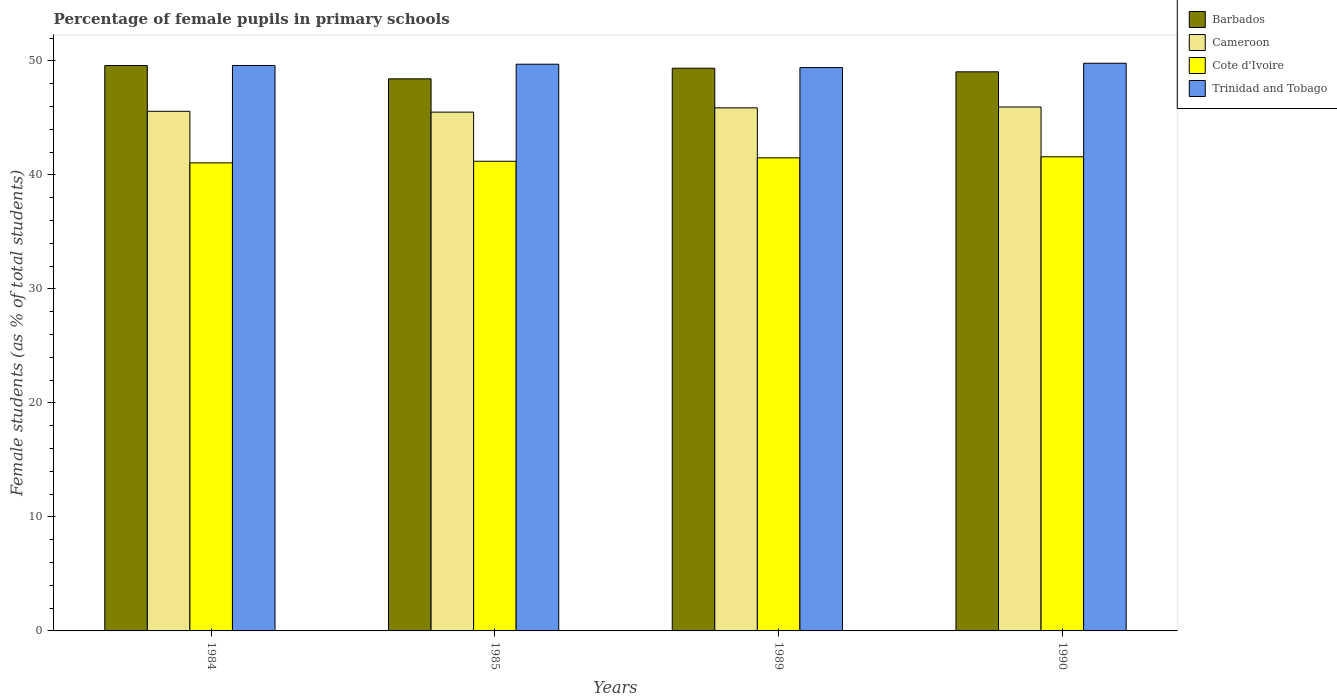How many groups of bars are there?
Your answer should be very brief. 4. Are the number of bars per tick equal to the number of legend labels?
Make the answer very short. Yes. Are the number of bars on each tick of the X-axis equal?
Make the answer very short. Yes. How many bars are there on the 2nd tick from the left?
Your answer should be very brief. 4. What is the label of the 1st group of bars from the left?
Your answer should be very brief. 1984. In how many cases, is the number of bars for a given year not equal to the number of legend labels?
Offer a terse response. 0. What is the percentage of female pupils in primary schools in Cameroon in 1985?
Your answer should be compact. 45.51. Across all years, what is the maximum percentage of female pupils in primary schools in Cote d'Ivoire?
Your answer should be compact. 41.59. Across all years, what is the minimum percentage of female pupils in primary schools in Barbados?
Your answer should be compact. 48.42. In which year was the percentage of female pupils in primary schools in Cameroon minimum?
Provide a short and direct response. 1985. What is the total percentage of female pupils in primary schools in Barbados in the graph?
Your answer should be very brief. 196.41. What is the difference between the percentage of female pupils in primary schools in Cameroon in 1989 and that in 1990?
Offer a terse response. -0.08. What is the difference between the percentage of female pupils in primary schools in Barbados in 1985 and the percentage of female pupils in primary schools in Cameroon in 1990?
Your answer should be compact. 2.47. What is the average percentage of female pupils in primary schools in Cote d'Ivoire per year?
Offer a very short reply. 41.33. In the year 1990, what is the difference between the percentage of female pupils in primary schools in Trinidad and Tobago and percentage of female pupils in primary schools in Cote d'Ivoire?
Your response must be concise. 8.2. What is the ratio of the percentage of female pupils in primary schools in Barbados in 1985 to that in 1990?
Make the answer very short. 0.99. Is the difference between the percentage of female pupils in primary schools in Trinidad and Tobago in 1984 and 1989 greater than the difference between the percentage of female pupils in primary schools in Cote d'Ivoire in 1984 and 1989?
Your response must be concise. Yes. What is the difference between the highest and the second highest percentage of female pupils in primary schools in Cote d'Ivoire?
Provide a succinct answer. 0.09. What is the difference between the highest and the lowest percentage of female pupils in primary schools in Barbados?
Provide a succinct answer. 1.17. What does the 3rd bar from the left in 1990 represents?
Give a very brief answer. Cote d'Ivoire. What does the 4th bar from the right in 1989 represents?
Make the answer very short. Barbados. How many bars are there?
Make the answer very short. 16. How many years are there in the graph?
Provide a succinct answer. 4. What is the difference between two consecutive major ticks on the Y-axis?
Your response must be concise. 10. Are the values on the major ticks of Y-axis written in scientific E-notation?
Ensure brevity in your answer.  No. Does the graph contain any zero values?
Provide a succinct answer. No. What is the title of the graph?
Offer a very short reply. Percentage of female pupils in primary schools. What is the label or title of the Y-axis?
Your response must be concise. Female students (as % of total students). What is the Female students (as % of total students) in Barbados in 1984?
Your response must be concise. 49.59. What is the Female students (as % of total students) of Cameroon in 1984?
Offer a terse response. 45.58. What is the Female students (as % of total students) of Cote d'Ivoire in 1984?
Your answer should be compact. 41.06. What is the Female students (as % of total students) of Trinidad and Tobago in 1984?
Provide a short and direct response. 49.59. What is the Female students (as % of total students) in Barbados in 1985?
Provide a short and direct response. 48.42. What is the Female students (as % of total students) in Cameroon in 1985?
Your answer should be compact. 45.51. What is the Female students (as % of total students) in Cote d'Ivoire in 1985?
Your answer should be very brief. 41.19. What is the Female students (as % of total students) of Trinidad and Tobago in 1985?
Make the answer very short. 49.71. What is the Female students (as % of total students) in Barbados in 1989?
Give a very brief answer. 49.35. What is the Female students (as % of total students) in Cameroon in 1989?
Your answer should be compact. 45.88. What is the Female students (as % of total students) in Cote d'Ivoire in 1989?
Your answer should be compact. 41.5. What is the Female students (as % of total students) of Trinidad and Tobago in 1989?
Offer a very short reply. 49.41. What is the Female students (as % of total students) in Barbados in 1990?
Make the answer very short. 49.04. What is the Female students (as % of total students) of Cameroon in 1990?
Offer a very short reply. 45.95. What is the Female students (as % of total students) of Cote d'Ivoire in 1990?
Keep it short and to the point. 41.59. What is the Female students (as % of total students) of Trinidad and Tobago in 1990?
Offer a terse response. 49.79. Across all years, what is the maximum Female students (as % of total students) in Barbados?
Make the answer very short. 49.59. Across all years, what is the maximum Female students (as % of total students) in Cameroon?
Offer a very short reply. 45.95. Across all years, what is the maximum Female students (as % of total students) of Cote d'Ivoire?
Your answer should be very brief. 41.59. Across all years, what is the maximum Female students (as % of total students) of Trinidad and Tobago?
Your answer should be very brief. 49.79. Across all years, what is the minimum Female students (as % of total students) in Barbados?
Ensure brevity in your answer.  48.42. Across all years, what is the minimum Female students (as % of total students) of Cameroon?
Provide a succinct answer. 45.51. Across all years, what is the minimum Female students (as % of total students) of Cote d'Ivoire?
Your answer should be very brief. 41.06. Across all years, what is the minimum Female students (as % of total students) of Trinidad and Tobago?
Your answer should be compact. 49.41. What is the total Female students (as % of total students) of Barbados in the graph?
Keep it short and to the point. 196.41. What is the total Female students (as % of total students) in Cameroon in the graph?
Your answer should be compact. 182.92. What is the total Female students (as % of total students) in Cote d'Ivoire in the graph?
Provide a short and direct response. 165.33. What is the total Female students (as % of total students) of Trinidad and Tobago in the graph?
Offer a terse response. 198.5. What is the difference between the Female students (as % of total students) of Barbados in 1984 and that in 1985?
Offer a very short reply. 1.17. What is the difference between the Female students (as % of total students) in Cameroon in 1984 and that in 1985?
Provide a short and direct response. 0.07. What is the difference between the Female students (as % of total students) of Cote d'Ivoire in 1984 and that in 1985?
Your answer should be very brief. -0.14. What is the difference between the Female students (as % of total students) of Trinidad and Tobago in 1984 and that in 1985?
Offer a very short reply. -0.11. What is the difference between the Female students (as % of total students) of Barbados in 1984 and that in 1989?
Offer a very short reply. 0.24. What is the difference between the Female students (as % of total students) in Cameroon in 1984 and that in 1989?
Ensure brevity in your answer.  -0.3. What is the difference between the Female students (as % of total students) in Cote d'Ivoire in 1984 and that in 1989?
Your response must be concise. -0.44. What is the difference between the Female students (as % of total students) of Trinidad and Tobago in 1984 and that in 1989?
Ensure brevity in your answer.  0.18. What is the difference between the Female students (as % of total students) of Barbados in 1984 and that in 1990?
Provide a succinct answer. 0.55. What is the difference between the Female students (as % of total students) in Cameroon in 1984 and that in 1990?
Offer a very short reply. -0.38. What is the difference between the Female students (as % of total students) in Cote d'Ivoire in 1984 and that in 1990?
Your response must be concise. -0.53. What is the difference between the Female students (as % of total students) of Trinidad and Tobago in 1984 and that in 1990?
Offer a terse response. -0.2. What is the difference between the Female students (as % of total students) in Barbados in 1985 and that in 1989?
Your answer should be compact. -0.93. What is the difference between the Female students (as % of total students) of Cameroon in 1985 and that in 1989?
Offer a terse response. -0.37. What is the difference between the Female students (as % of total students) in Cote d'Ivoire in 1985 and that in 1989?
Provide a short and direct response. -0.3. What is the difference between the Female students (as % of total students) of Trinidad and Tobago in 1985 and that in 1989?
Make the answer very short. 0.3. What is the difference between the Female students (as % of total students) of Barbados in 1985 and that in 1990?
Offer a terse response. -0.62. What is the difference between the Female students (as % of total students) in Cameroon in 1985 and that in 1990?
Your response must be concise. -0.45. What is the difference between the Female students (as % of total students) of Cote d'Ivoire in 1985 and that in 1990?
Offer a terse response. -0.39. What is the difference between the Female students (as % of total students) of Trinidad and Tobago in 1985 and that in 1990?
Make the answer very short. -0.08. What is the difference between the Female students (as % of total students) of Barbados in 1989 and that in 1990?
Your answer should be very brief. 0.32. What is the difference between the Female students (as % of total students) in Cameroon in 1989 and that in 1990?
Give a very brief answer. -0.08. What is the difference between the Female students (as % of total students) of Cote d'Ivoire in 1989 and that in 1990?
Offer a very short reply. -0.09. What is the difference between the Female students (as % of total students) in Trinidad and Tobago in 1989 and that in 1990?
Your answer should be very brief. -0.38. What is the difference between the Female students (as % of total students) in Barbados in 1984 and the Female students (as % of total students) in Cameroon in 1985?
Provide a succinct answer. 4.09. What is the difference between the Female students (as % of total students) of Barbados in 1984 and the Female students (as % of total students) of Cote d'Ivoire in 1985?
Make the answer very short. 8.4. What is the difference between the Female students (as % of total students) in Barbados in 1984 and the Female students (as % of total students) in Trinidad and Tobago in 1985?
Offer a terse response. -0.12. What is the difference between the Female students (as % of total students) of Cameroon in 1984 and the Female students (as % of total students) of Cote d'Ivoire in 1985?
Offer a terse response. 4.38. What is the difference between the Female students (as % of total students) in Cameroon in 1984 and the Female students (as % of total students) in Trinidad and Tobago in 1985?
Keep it short and to the point. -4.13. What is the difference between the Female students (as % of total students) in Cote d'Ivoire in 1984 and the Female students (as % of total students) in Trinidad and Tobago in 1985?
Offer a terse response. -8.65. What is the difference between the Female students (as % of total students) in Barbados in 1984 and the Female students (as % of total students) in Cameroon in 1989?
Your answer should be compact. 3.71. What is the difference between the Female students (as % of total students) of Barbados in 1984 and the Female students (as % of total students) of Cote d'Ivoire in 1989?
Offer a very short reply. 8.1. What is the difference between the Female students (as % of total students) in Barbados in 1984 and the Female students (as % of total students) in Trinidad and Tobago in 1989?
Ensure brevity in your answer.  0.18. What is the difference between the Female students (as % of total students) in Cameroon in 1984 and the Female students (as % of total students) in Cote d'Ivoire in 1989?
Provide a short and direct response. 4.08. What is the difference between the Female students (as % of total students) of Cameroon in 1984 and the Female students (as % of total students) of Trinidad and Tobago in 1989?
Give a very brief answer. -3.83. What is the difference between the Female students (as % of total students) in Cote d'Ivoire in 1984 and the Female students (as % of total students) in Trinidad and Tobago in 1989?
Keep it short and to the point. -8.36. What is the difference between the Female students (as % of total students) of Barbados in 1984 and the Female students (as % of total students) of Cameroon in 1990?
Give a very brief answer. 3.64. What is the difference between the Female students (as % of total students) in Barbados in 1984 and the Female students (as % of total students) in Cote d'Ivoire in 1990?
Offer a terse response. 8. What is the difference between the Female students (as % of total students) of Barbados in 1984 and the Female students (as % of total students) of Trinidad and Tobago in 1990?
Keep it short and to the point. -0.2. What is the difference between the Female students (as % of total students) in Cameroon in 1984 and the Female students (as % of total students) in Cote d'Ivoire in 1990?
Your answer should be compact. 3.99. What is the difference between the Female students (as % of total students) in Cameroon in 1984 and the Female students (as % of total students) in Trinidad and Tobago in 1990?
Ensure brevity in your answer.  -4.21. What is the difference between the Female students (as % of total students) in Cote d'Ivoire in 1984 and the Female students (as % of total students) in Trinidad and Tobago in 1990?
Provide a short and direct response. -8.73. What is the difference between the Female students (as % of total students) in Barbados in 1985 and the Female students (as % of total students) in Cameroon in 1989?
Ensure brevity in your answer.  2.54. What is the difference between the Female students (as % of total students) in Barbados in 1985 and the Female students (as % of total students) in Cote d'Ivoire in 1989?
Offer a very short reply. 6.93. What is the difference between the Female students (as % of total students) in Barbados in 1985 and the Female students (as % of total students) in Trinidad and Tobago in 1989?
Your answer should be compact. -0.99. What is the difference between the Female students (as % of total students) in Cameroon in 1985 and the Female students (as % of total students) in Cote d'Ivoire in 1989?
Offer a very short reply. 4.01. What is the difference between the Female students (as % of total students) of Cameroon in 1985 and the Female students (as % of total students) of Trinidad and Tobago in 1989?
Provide a succinct answer. -3.91. What is the difference between the Female students (as % of total students) in Cote d'Ivoire in 1985 and the Female students (as % of total students) in Trinidad and Tobago in 1989?
Keep it short and to the point. -8.22. What is the difference between the Female students (as % of total students) in Barbados in 1985 and the Female students (as % of total students) in Cameroon in 1990?
Offer a very short reply. 2.47. What is the difference between the Female students (as % of total students) in Barbados in 1985 and the Female students (as % of total students) in Cote d'Ivoire in 1990?
Offer a terse response. 6.84. What is the difference between the Female students (as % of total students) of Barbados in 1985 and the Female students (as % of total students) of Trinidad and Tobago in 1990?
Offer a terse response. -1.37. What is the difference between the Female students (as % of total students) of Cameroon in 1985 and the Female students (as % of total students) of Cote d'Ivoire in 1990?
Offer a terse response. 3.92. What is the difference between the Female students (as % of total students) of Cameroon in 1985 and the Female students (as % of total students) of Trinidad and Tobago in 1990?
Your answer should be compact. -4.29. What is the difference between the Female students (as % of total students) in Cote d'Ivoire in 1985 and the Female students (as % of total students) in Trinidad and Tobago in 1990?
Offer a very short reply. -8.6. What is the difference between the Female students (as % of total students) of Barbados in 1989 and the Female students (as % of total students) of Cameroon in 1990?
Provide a short and direct response. 3.4. What is the difference between the Female students (as % of total students) in Barbados in 1989 and the Female students (as % of total students) in Cote d'Ivoire in 1990?
Ensure brevity in your answer.  7.77. What is the difference between the Female students (as % of total students) in Barbados in 1989 and the Female students (as % of total students) in Trinidad and Tobago in 1990?
Offer a very short reply. -0.44. What is the difference between the Female students (as % of total students) of Cameroon in 1989 and the Female students (as % of total students) of Cote d'Ivoire in 1990?
Your answer should be very brief. 4.29. What is the difference between the Female students (as % of total students) of Cameroon in 1989 and the Female students (as % of total students) of Trinidad and Tobago in 1990?
Keep it short and to the point. -3.91. What is the difference between the Female students (as % of total students) in Cote d'Ivoire in 1989 and the Female students (as % of total students) in Trinidad and Tobago in 1990?
Give a very brief answer. -8.3. What is the average Female students (as % of total students) in Barbados per year?
Provide a succinct answer. 49.1. What is the average Female students (as % of total students) in Cameroon per year?
Your answer should be compact. 45.73. What is the average Female students (as % of total students) in Cote d'Ivoire per year?
Your response must be concise. 41.33. What is the average Female students (as % of total students) of Trinidad and Tobago per year?
Your answer should be compact. 49.63. In the year 1984, what is the difference between the Female students (as % of total students) in Barbados and Female students (as % of total students) in Cameroon?
Your answer should be very brief. 4.01. In the year 1984, what is the difference between the Female students (as % of total students) of Barbados and Female students (as % of total students) of Cote d'Ivoire?
Your response must be concise. 8.54. In the year 1984, what is the difference between the Female students (as % of total students) in Barbados and Female students (as % of total students) in Trinidad and Tobago?
Your answer should be compact. -0. In the year 1984, what is the difference between the Female students (as % of total students) in Cameroon and Female students (as % of total students) in Cote d'Ivoire?
Your answer should be compact. 4.52. In the year 1984, what is the difference between the Female students (as % of total students) of Cameroon and Female students (as % of total students) of Trinidad and Tobago?
Keep it short and to the point. -4.02. In the year 1984, what is the difference between the Female students (as % of total students) of Cote d'Ivoire and Female students (as % of total students) of Trinidad and Tobago?
Give a very brief answer. -8.54. In the year 1985, what is the difference between the Female students (as % of total students) of Barbados and Female students (as % of total students) of Cameroon?
Make the answer very short. 2.92. In the year 1985, what is the difference between the Female students (as % of total students) of Barbados and Female students (as % of total students) of Cote d'Ivoire?
Ensure brevity in your answer.  7.23. In the year 1985, what is the difference between the Female students (as % of total students) of Barbados and Female students (as % of total students) of Trinidad and Tobago?
Provide a short and direct response. -1.28. In the year 1985, what is the difference between the Female students (as % of total students) of Cameroon and Female students (as % of total students) of Cote d'Ivoire?
Keep it short and to the point. 4.31. In the year 1985, what is the difference between the Female students (as % of total students) of Cameroon and Female students (as % of total students) of Trinidad and Tobago?
Your response must be concise. -4.2. In the year 1985, what is the difference between the Female students (as % of total students) in Cote d'Ivoire and Female students (as % of total students) in Trinidad and Tobago?
Offer a terse response. -8.51. In the year 1989, what is the difference between the Female students (as % of total students) of Barbados and Female students (as % of total students) of Cameroon?
Your answer should be very brief. 3.48. In the year 1989, what is the difference between the Female students (as % of total students) in Barbados and Female students (as % of total students) in Cote d'Ivoire?
Give a very brief answer. 7.86. In the year 1989, what is the difference between the Female students (as % of total students) in Barbados and Female students (as % of total students) in Trinidad and Tobago?
Provide a short and direct response. -0.06. In the year 1989, what is the difference between the Female students (as % of total students) in Cameroon and Female students (as % of total students) in Cote d'Ivoire?
Your answer should be compact. 4.38. In the year 1989, what is the difference between the Female students (as % of total students) in Cameroon and Female students (as % of total students) in Trinidad and Tobago?
Make the answer very short. -3.53. In the year 1989, what is the difference between the Female students (as % of total students) in Cote d'Ivoire and Female students (as % of total students) in Trinidad and Tobago?
Your response must be concise. -7.92. In the year 1990, what is the difference between the Female students (as % of total students) in Barbados and Female students (as % of total students) in Cameroon?
Keep it short and to the point. 3.08. In the year 1990, what is the difference between the Female students (as % of total students) in Barbados and Female students (as % of total students) in Cote d'Ivoire?
Provide a succinct answer. 7.45. In the year 1990, what is the difference between the Female students (as % of total students) of Barbados and Female students (as % of total students) of Trinidad and Tobago?
Keep it short and to the point. -0.75. In the year 1990, what is the difference between the Female students (as % of total students) in Cameroon and Female students (as % of total students) in Cote d'Ivoire?
Keep it short and to the point. 4.37. In the year 1990, what is the difference between the Female students (as % of total students) of Cameroon and Female students (as % of total students) of Trinidad and Tobago?
Your response must be concise. -3.84. In the year 1990, what is the difference between the Female students (as % of total students) in Cote d'Ivoire and Female students (as % of total students) in Trinidad and Tobago?
Keep it short and to the point. -8.2. What is the ratio of the Female students (as % of total students) in Barbados in 1984 to that in 1985?
Keep it short and to the point. 1.02. What is the ratio of the Female students (as % of total students) in Cameroon in 1984 to that in 1985?
Give a very brief answer. 1. What is the ratio of the Female students (as % of total students) in Barbados in 1984 to that in 1989?
Give a very brief answer. 1. What is the ratio of the Female students (as % of total students) of Cote d'Ivoire in 1984 to that in 1989?
Your answer should be very brief. 0.99. What is the ratio of the Female students (as % of total students) in Trinidad and Tobago in 1984 to that in 1989?
Provide a short and direct response. 1. What is the ratio of the Female students (as % of total students) in Barbados in 1984 to that in 1990?
Provide a succinct answer. 1.01. What is the ratio of the Female students (as % of total students) of Cameroon in 1984 to that in 1990?
Your answer should be compact. 0.99. What is the ratio of the Female students (as % of total students) in Cote d'Ivoire in 1984 to that in 1990?
Give a very brief answer. 0.99. What is the ratio of the Female students (as % of total students) of Barbados in 1985 to that in 1989?
Your answer should be compact. 0.98. What is the ratio of the Female students (as % of total students) of Trinidad and Tobago in 1985 to that in 1989?
Offer a terse response. 1.01. What is the ratio of the Female students (as % of total students) of Barbados in 1985 to that in 1990?
Give a very brief answer. 0.99. What is the ratio of the Female students (as % of total students) of Cameroon in 1985 to that in 1990?
Keep it short and to the point. 0.99. What is the ratio of the Female students (as % of total students) of Cote d'Ivoire in 1985 to that in 1990?
Make the answer very short. 0.99. What is the ratio of the Female students (as % of total students) of Barbados in 1989 to that in 1990?
Your response must be concise. 1.01. What is the ratio of the Female students (as % of total students) in Cameroon in 1989 to that in 1990?
Ensure brevity in your answer.  1. What is the ratio of the Female students (as % of total students) in Cote d'Ivoire in 1989 to that in 1990?
Your answer should be very brief. 1. What is the ratio of the Female students (as % of total students) of Trinidad and Tobago in 1989 to that in 1990?
Your answer should be compact. 0.99. What is the difference between the highest and the second highest Female students (as % of total students) in Barbados?
Your answer should be compact. 0.24. What is the difference between the highest and the second highest Female students (as % of total students) of Cameroon?
Offer a very short reply. 0.08. What is the difference between the highest and the second highest Female students (as % of total students) of Cote d'Ivoire?
Provide a succinct answer. 0.09. What is the difference between the highest and the second highest Female students (as % of total students) of Trinidad and Tobago?
Give a very brief answer. 0.08. What is the difference between the highest and the lowest Female students (as % of total students) of Barbados?
Ensure brevity in your answer.  1.17. What is the difference between the highest and the lowest Female students (as % of total students) of Cameroon?
Ensure brevity in your answer.  0.45. What is the difference between the highest and the lowest Female students (as % of total students) in Cote d'Ivoire?
Make the answer very short. 0.53. What is the difference between the highest and the lowest Female students (as % of total students) of Trinidad and Tobago?
Give a very brief answer. 0.38. 